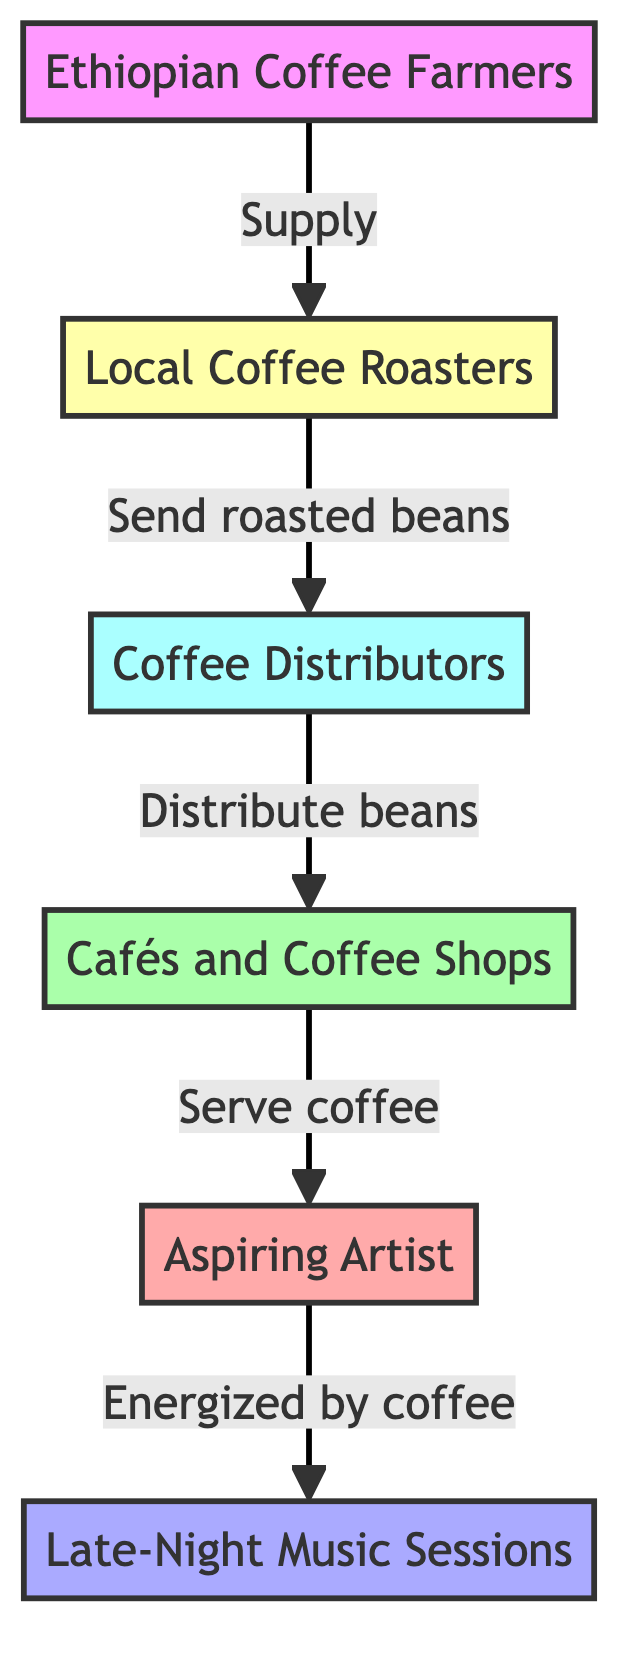What is the first node in the diagram? The first node listed in the diagram is "Ethiopian Coffee Farmers," indicating that this is the starting point of the food chain.
Answer: Ethiopian Coffee Farmers How many nodes are present in the diagram? There are six nodes present in the diagram: Ethiopian Coffee Farmers, Local Coffee Roasters, Coffee Distributors, Cafés and Coffee Shops, Aspiring Artist, and Late-Night Music Sessions.
Answer: Six What relationship exists between Local Coffee Roasters and Coffee Distributors? The relationship is defined as "Send roasted beans," which describes the action taken by Local Coffee Roasters towards Coffee Distributors.
Answer: Send roasted beans Who receives coffee from the Cafés and Coffee Shops? The node "Aspiring Artist" receives coffee from the Cafés and Coffee Shops, as indicated by the connection between these two nodes.
Answer: Aspiring Artist What energizes the Late-Night Music Sessions? The Late-Night Music Sessions are energized by coffee, as shown by the direct link from the Aspiring Artist receiving coffee to this node.
Answer: Coffee What is the last connection made in the diagram? The last connection is from the Aspiring Artist to the Late-Night Music Sessions, which completes the flow of energy from coffee to the artist's late-night activities.
Answer: Aspiring Artist to Late-Night Music Sessions What is the role of Coffee Distributors in the food chain? Coffee Distributors serve the role of distributing beans to Cafés and Coffee Shops, linking the roasting process to the final consumer access point.
Answer: Distribute beans Which node is positioned directly before the Aspiring Artist in the flow? The node positioned directly before the Aspiring Artist is "Cafés and Coffee Shops," indicating the flow sequence to the artist.
Answer: Cafés and Coffee Shops 